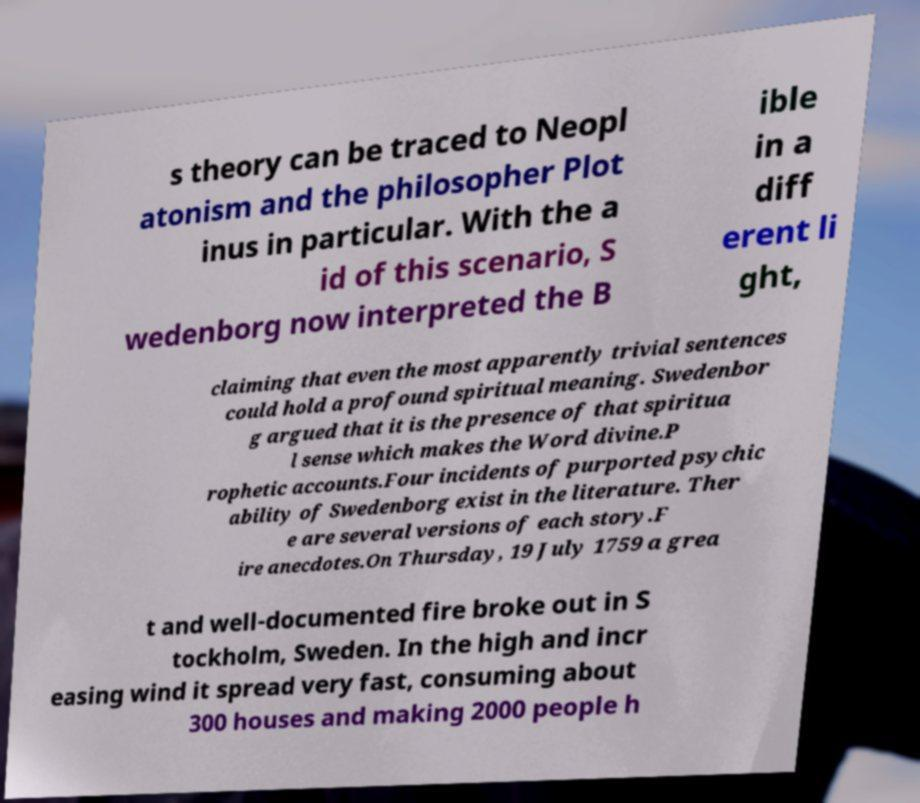Can you read and provide the text displayed in the image?This photo seems to have some interesting text. Can you extract and type it out for me? s theory can be traced to Neopl atonism and the philosopher Plot inus in particular. With the a id of this scenario, S wedenborg now interpreted the B ible in a diff erent li ght, claiming that even the most apparently trivial sentences could hold a profound spiritual meaning. Swedenbor g argued that it is the presence of that spiritua l sense which makes the Word divine.P rophetic accounts.Four incidents of purported psychic ability of Swedenborg exist in the literature. Ther e are several versions of each story.F ire anecdotes.On Thursday, 19 July 1759 a grea t and well-documented fire broke out in S tockholm, Sweden. In the high and incr easing wind it spread very fast, consuming about 300 houses and making 2000 people h 